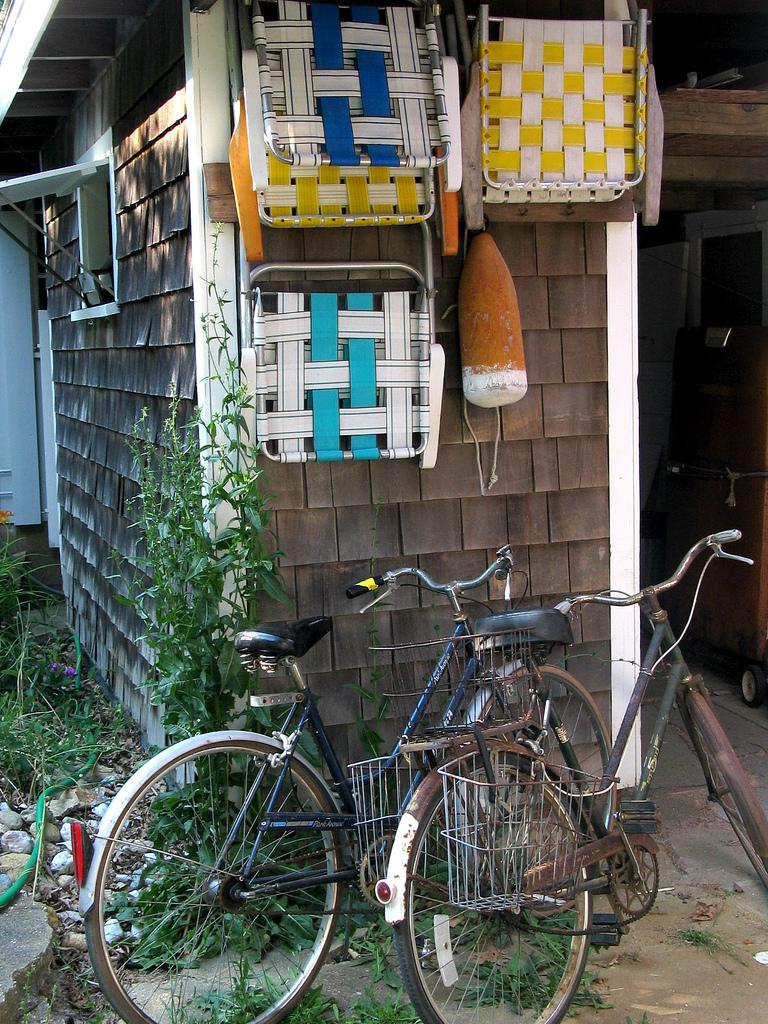Question: what kind of stripes do the lawn chairs have?
Choices:
A. Black.
B. Gray.
C. White.
D. Yellow.
Answer with the letter. Answer: C Question: where are the chairs?
Choices:
A. Sitting at the table.
B. In the dining room.
C. Hanging on the wall.
D. In the kitchen.
Answer with the letter. Answer: C Question: how many bikes are there?
Choices:
A. Three.
B. Six.
C. Ten.
D. Two.
Answer with the letter. Answer: D Question: where is this location?
Choices:
A. Garage.
B. Livingroom.
C. Bathroom.
D. Backyard.
Answer with the letter. Answer: A Question: what position is the window?
Choices:
A. Open.
B. Shut.
C. Up.
D. Down.
Answer with the letter. Answer: A Question: what position is the garage door?
Choices:
A. Down.
B. Pause.
C. Up.
D. Reset.
Answer with the letter. Answer: C Question: what runs along the house?
Choices:
A. A garden hose.
B. Flower bed.
C. Trash.
D. Plants.
Answer with the letter. Answer: A Question: what is in the picture?
Choices:
A. A white house with two lawn chairs and one bike.
B. A blue house with four lawn chairs and one car.
C. A brown house with three lawn chairs and two bikes.
D. A blue house with four lawn chairs and two cars.
Answer with the letter. Answer: C Question: what does the house have?
Choices:
A. Old brown siding.
B. Broken shutters.
C. Loose shingles.
D. Picture windows.
Answer with the letter. Answer: A Question: where is the plant?
Choices:
A. In the yard.
B. On the corner of the house.
C. In the planter.
D. In the vase.
Answer with the letter. Answer: B Question: what does the bike in back look like?
Choices:
A. Old.
B. New.
C. Rusty.
D. Broken.
Answer with the letter. Answer: B Question: what does the bike in front look like?
Choices:
A. Old.
B. New.
C. Broken.
D. Rusty.
Answer with the letter. Answer: D Question: what is happening with the window on the side of the house?
Choices:
A. It is closed.
B. It is propped open.
C. It is broken.
D. It is dirty.
Answer with the letter. Answer: B Question: who are growing tall?
Choices:
A. Weeds.
B. Trees.
C. Children.
D. Boys.
Answer with the letter. Answer: A Question: what looks old?
Choices:
A. Bikes.
B. Skateboards.
C. Halfpipe.
D. Railings.
Answer with the letter. Answer: A Question: what is on ground?
Choices:
A. Pile of dirt.
B. Grass.
C. Pile of rocks.
D. Mud puddles.
Answer with the letter. Answer: C 